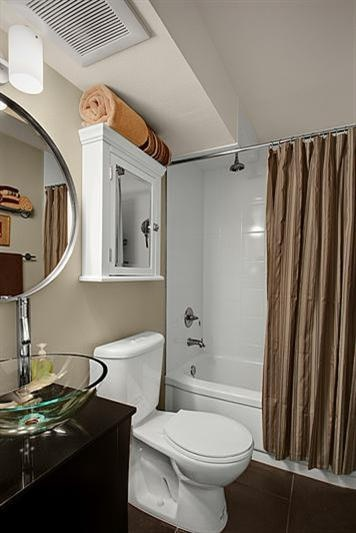Describe the objects in this image and their specific colors. I can see toilet in darkgray, lightgray, and gray tones and sink in darkgray, gray, and black tones in this image. 